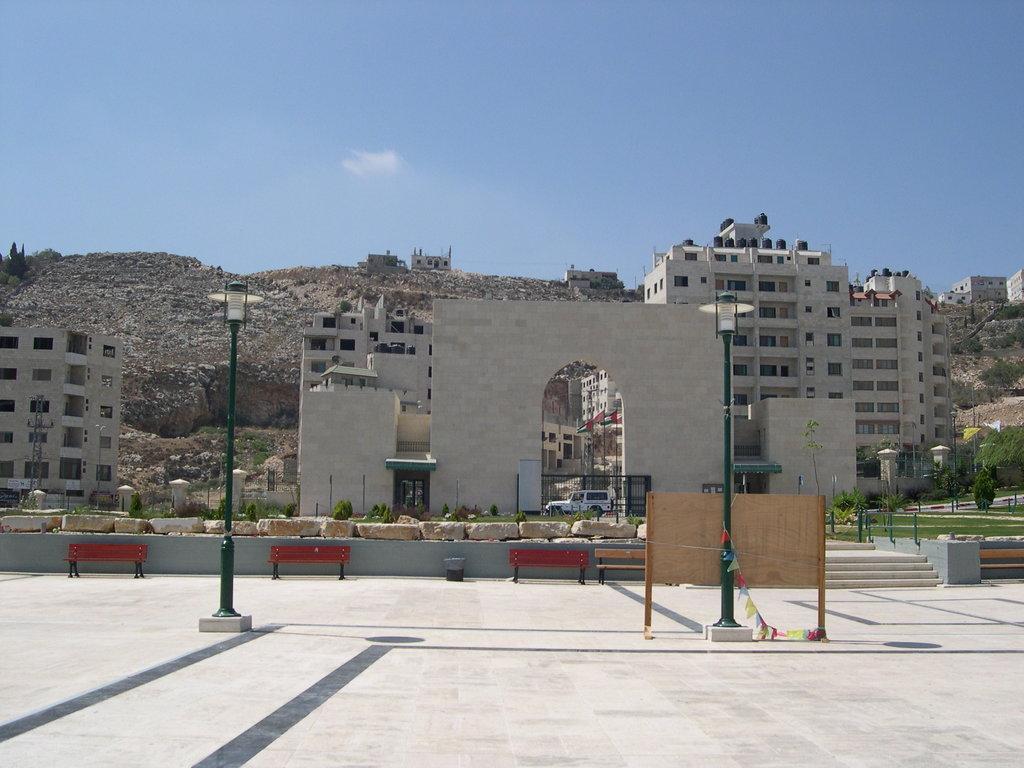Describe this image in one or two sentences. This image is clicked outside. In the front, we can see a two poles along with the lights. In the background, there are buildings along with a mountain. At the top, there is sky. In the middle, we can see three benches. 